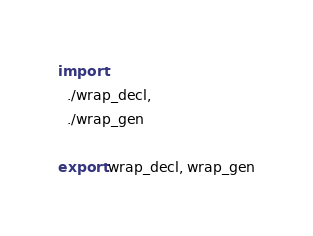Convert code to text. <code><loc_0><loc_0><loc_500><loc_500><_Nim_>import
  ./wrap_decl,
  ./wrap_gen

export wrap_decl, wrap_gen
</code> 